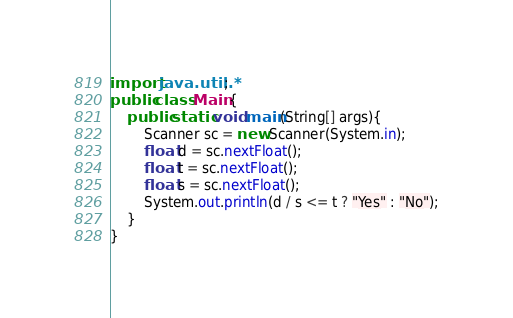Convert code to text. <code><loc_0><loc_0><loc_500><loc_500><_Java_>import java.util.*;
public class Main {
	public static void main(String[] args){
        Scanner sc = new Scanner(System.in);
        float d = sc.nextFloat();
        float t = sc.nextFloat();
        float s = sc.nextFloat();
        System.out.println(d / s <= t ? "Yes" : "No");
	}
}</code> 